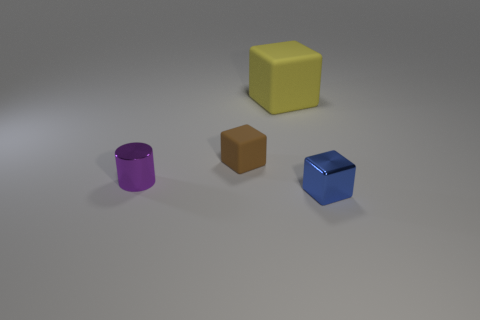Is there anything else that is the same color as the tiny shiny cylinder?
Ensure brevity in your answer.  No. There is a brown thing that is the same shape as the blue object; what is it made of?
Provide a succinct answer. Rubber. How many other objects are there of the same size as the purple metal cylinder?
Your answer should be compact. 2. What is the material of the small blue block?
Give a very brief answer. Metal. Are there more small shiny things that are on the left side of the large block than small yellow matte cylinders?
Provide a succinct answer. Yes. Are there any large yellow objects?
Your answer should be very brief. Yes. What number of other objects are there of the same shape as the big rubber thing?
Give a very brief answer. 2. There is a rubber block behind the small cube that is left of the blue metal object that is in front of the tiny brown rubber object; what is its size?
Offer a very short reply. Large. What is the shape of the object that is both in front of the brown object and right of the brown matte block?
Give a very brief answer. Cube. Are there the same number of tiny matte objects that are behind the tiny shiny cylinder and big yellow cubes to the right of the tiny metal block?
Your answer should be very brief. No. 